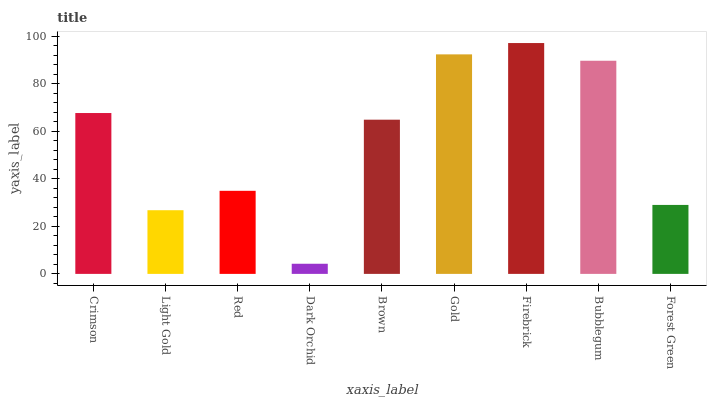Is Dark Orchid the minimum?
Answer yes or no. Yes. Is Firebrick the maximum?
Answer yes or no. Yes. Is Light Gold the minimum?
Answer yes or no. No. Is Light Gold the maximum?
Answer yes or no. No. Is Crimson greater than Light Gold?
Answer yes or no. Yes. Is Light Gold less than Crimson?
Answer yes or no. Yes. Is Light Gold greater than Crimson?
Answer yes or no. No. Is Crimson less than Light Gold?
Answer yes or no. No. Is Brown the high median?
Answer yes or no. Yes. Is Brown the low median?
Answer yes or no. Yes. Is Light Gold the high median?
Answer yes or no. No. Is Bubblegum the low median?
Answer yes or no. No. 